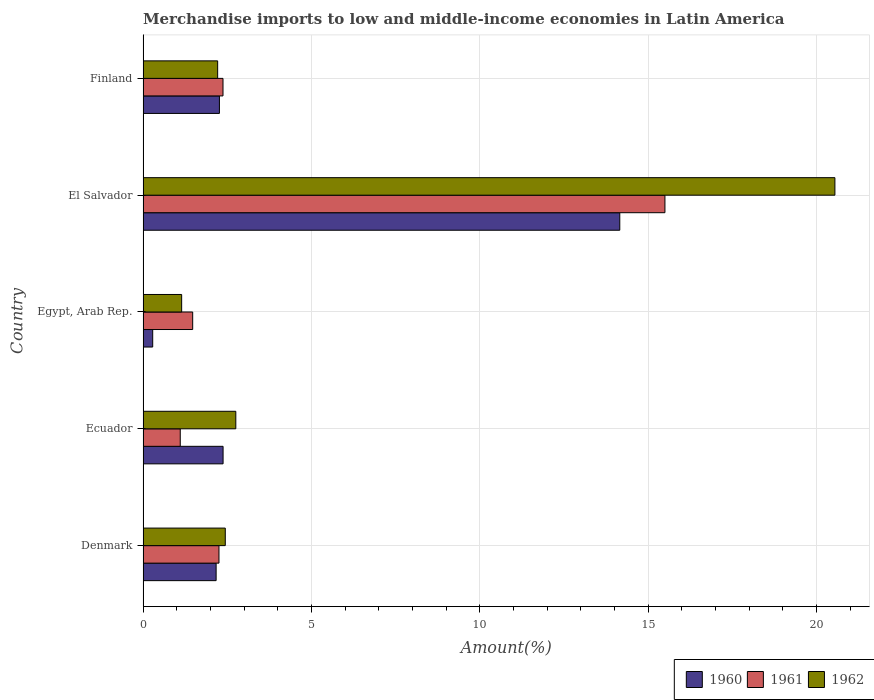How many groups of bars are there?
Make the answer very short. 5. Are the number of bars on each tick of the Y-axis equal?
Your answer should be compact. Yes. What is the label of the 4th group of bars from the top?
Your answer should be very brief. Ecuador. In how many cases, is the number of bars for a given country not equal to the number of legend labels?
Offer a very short reply. 0. What is the percentage of amount earned from merchandise imports in 1961 in Ecuador?
Offer a very short reply. 1.1. Across all countries, what is the maximum percentage of amount earned from merchandise imports in 1962?
Offer a terse response. 20.55. Across all countries, what is the minimum percentage of amount earned from merchandise imports in 1962?
Ensure brevity in your answer.  1.15. In which country was the percentage of amount earned from merchandise imports in 1961 maximum?
Your answer should be compact. El Salvador. In which country was the percentage of amount earned from merchandise imports in 1961 minimum?
Ensure brevity in your answer.  Ecuador. What is the total percentage of amount earned from merchandise imports in 1961 in the graph?
Give a very brief answer. 22.7. What is the difference between the percentage of amount earned from merchandise imports in 1962 in Ecuador and that in El Salvador?
Make the answer very short. -17.79. What is the difference between the percentage of amount earned from merchandise imports in 1961 in El Salvador and the percentage of amount earned from merchandise imports in 1962 in Ecuador?
Your answer should be very brief. 12.74. What is the average percentage of amount earned from merchandise imports in 1961 per country?
Offer a terse response. 4.54. What is the difference between the percentage of amount earned from merchandise imports in 1960 and percentage of amount earned from merchandise imports in 1962 in Finland?
Your response must be concise. 0.05. What is the ratio of the percentage of amount earned from merchandise imports in 1961 in Egypt, Arab Rep. to that in El Salvador?
Offer a very short reply. 0.1. What is the difference between the highest and the second highest percentage of amount earned from merchandise imports in 1960?
Ensure brevity in your answer.  11.78. What is the difference between the highest and the lowest percentage of amount earned from merchandise imports in 1962?
Ensure brevity in your answer.  19.4. In how many countries, is the percentage of amount earned from merchandise imports in 1962 greater than the average percentage of amount earned from merchandise imports in 1962 taken over all countries?
Ensure brevity in your answer.  1. Is the sum of the percentage of amount earned from merchandise imports in 1962 in Denmark and Ecuador greater than the maximum percentage of amount earned from merchandise imports in 1960 across all countries?
Your answer should be compact. No. What does the 2nd bar from the top in Ecuador represents?
Provide a succinct answer. 1961. What does the 3rd bar from the bottom in Ecuador represents?
Ensure brevity in your answer.  1962. Are all the bars in the graph horizontal?
Offer a terse response. Yes. Does the graph contain any zero values?
Provide a short and direct response. No. How many legend labels are there?
Your response must be concise. 3. What is the title of the graph?
Keep it short and to the point. Merchandise imports to low and middle-income economies in Latin America. What is the label or title of the X-axis?
Offer a terse response. Amount(%). What is the Amount(%) of 1960 in Denmark?
Make the answer very short. 2.17. What is the Amount(%) in 1961 in Denmark?
Ensure brevity in your answer.  2.25. What is the Amount(%) of 1962 in Denmark?
Provide a short and direct response. 2.44. What is the Amount(%) of 1960 in Ecuador?
Give a very brief answer. 2.38. What is the Amount(%) of 1961 in Ecuador?
Offer a terse response. 1.1. What is the Amount(%) of 1962 in Ecuador?
Offer a very short reply. 2.75. What is the Amount(%) of 1960 in Egypt, Arab Rep.?
Your answer should be very brief. 0.29. What is the Amount(%) of 1961 in Egypt, Arab Rep.?
Offer a terse response. 1.47. What is the Amount(%) in 1962 in Egypt, Arab Rep.?
Keep it short and to the point. 1.15. What is the Amount(%) in 1960 in El Salvador?
Keep it short and to the point. 14.16. What is the Amount(%) in 1961 in El Salvador?
Ensure brevity in your answer.  15.5. What is the Amount(%) of 1962 in El Salvador?
Your response must be concise. 20.55. What is the Amount(%) in 1960 in Finland?
Offer a terse response. 2.27. What is the Amount(%) of 1961 in Finland?
Provide a succinct answer. 2.37. What is the Amount(%) in 1962 in Finland?
Keep it short and to the point. 2.22. Across all countries, what is the maximum Amount(%) in 1960?
Your response must be concise. 14.16. Across all countries, what is the maximum Amount(%) in 1961?
Offer a terse response. 15.5. Across all countries, what is the maximum Amount(%) in 1962?
Your answer should be very brief. 20.55. Across all countries, what is the minimum Amount(%) in 1960?
Provide a succinct answer. 0.29. Across all countries, what is the minimum Amount(%) of 1961?
Provide a succinct answer. 1.1. Across all countries, what is the minimum Amount(%) in 1962?
Give a very brief answer. 1.15. What is the total Amount(%) of 1960 in the graph?
Keep it short and to the point. 21.26. What is the total Amount(%) in 1961 in the graph?
Keep it short and to the point. 22.7. What is the total Amount(%) of 1962 in the graph?
Your answer should be very brief. 29.1. What is the difference between the Amount(%) in 1960 in Denmark and that in Ecuador?
Ensure brevity in your answer.  -0.21. What is the difference between the Amount(%) in 1961 in Denmark and that in Ecuador?
Keep it short and to the point. 1.15. What is the difference between the Amount(%) in 1962 in Denmark and that in Ecuador?
Ensure brevity in your answer.  -0.31. What is the difference between the Amount(%) in 1960 in Denmark and that in Egypt, Arab Rep.?
Give a very brief answer. 1.88. What is the difference between the Amount(%) in 1961 in Denmark and that in Egypt, Arab Rep.?
Give a very brief answer. 0.78. What is the difference between the Amount(%) in 1962 in Denmark and that in Egypt, Arab Rep.?
Provide a short and direct response. 1.3. What is the difference between the Amount(%) of 1960 in Denmark and that in El Salvador?
Offer a very short reply. -11.99. What is the difference between the Amount(%) of 1961 in Denmark and that in El Salvador?
Keep it short and to the point. -13.24. What is the difference between the Amount(%) of 1962 in Denmark and that in El Salvador?
Give a very brief answer. -18.1. What is the difference between the Amount(%) of 1960 in Denmark and that in Finland?
Make the answer very short. -0.1. What is the difference between the Amount(%) of 1961 in Denmark and that in Finland?
Offer a very short reply. -0.12. What is the difference between the Amount(%) of 1962 in Denmark and that in Finland?
Give a very brief answer. 0.23. What is the difference between the Amount(%) in 1960 in Ecuador and that in Egypt, Arab Rep.?
Your answer should be very brief. 2.09. What is the difference between the Amount(%) of 1961 in Ecuador and that in Egypt, Arab Rep.?
Your answer should be very brief. -0.37. What is the difference between the Amount(%) in 1962 in Ecuador and that in Egypt, Arab Rep.?
Provide a succinct answer. 1.61. What is the difference between the Amount(%) in 1960 in Ecuador and that in El Salvador?
Keep it short and to the point. -11.78. What is the difference between the Amount(%) in 1961 in Ecuador and that in El Salvador?
Keep it short and to the point. -14.39. What is the difference between the Amount(%) of 1962 in Ecuador and that in El Salvador?
Provide a short and direct response. -17.79. What is the difference between the Amount(%) in 1960 in Ecuador and that in Finland?
Offer a very short reply. 0.11. What is the difference between the Amount(%) in 1961 in Ecuador and that in Finland?
Keep it short and to the point. -1.27. What is the difference between the Amount(%) in 1962 in Ecuador and that in Finland?
Your answer should be compact. 0.54. What is the difference between the Amount(%) in 1960 in Egypt, Arab Rep. and that in El Salvador?
Offer a terse response. -13.87. What is the difference between the Amount(%) in 1961 in Egypt, Arab Rep. and that in El Salvador?
Your answer should be very brief. -14.02. What is the difference between the Amount(%) in 1962 in Egypt, Arab Rep. and that in El Salvador?
Offer a terse response. -19.4. What is the difference between the Amount(%) in 1960 in Egypt, Arab Rep. and that in Finland?
Offer a terse response. -1.98. What is the difference between the Amount(%) of 1961 in Egypt, Arab Rep. and that in Finland?
Ensure brevity in your answer.  -0.9. What is the difference between the Amount(%) in 1962 in Egypt, Arab Rep. and that in Finland?
Your response must be concise. -1.07. What is the difference between the Amount(%) in 1960 in El Salvador and that in Finland?
Provide a short and direct response. 11.89. What is the difference between the Amount(%) of 1961 in El Salvador and that in Finland?
Offer a very short reply. 13.12. What is the difference between the Amount(%) of 1962 in El Salvador and that in Finland?
Provide a short and direct response. 18.33. What is the difference between the Amount(%) in 1960 in Denmark and the Amount(%) in 1961 in Ecuador?
Make the answer very short. 1.07. What is the difference between the Amount(%) in 1960 in Denmark and the Amount(%) in 1962 in Ecuador?
Provide a succinct answer. -0.58. What is the difference between the Amount(%) of 1961 in Denmark and the Amount(%) of 1962 in Ecuador?
Make the answer very short. -0.5. What is the difference between the Amount(%) in 1960 in Denmark and the Amount(%) in 1961 in Egypt, Arab Rep.?
Your answer should be very brief. 0.7. What is the difference between the Amount(%) in 1960 in Denmark and the Amount(%) in 1962 in Egypt, Arab Rep.?
Offer a very short reply. 1.02. What is the difference between the Amount(%) in 1961 in Denmark and the Amount(%) in 1962 in Egypt, Arab Rep.?
Provide a succinct answer. 1.11. What is the difference between the Amount(%) in 1960 in Denmark and the Amount(%) in 1961 in El Salvador?
Give a very brief answer. -13.33. What is the difference between the Amount(%) in 1960 in Denmark and the Amount(%) in 1962 in El Salvador?
Offer a very short reply. -18.38. What is the difference between the Amount(%) of 1961 in Denmark and the Amount(%) of 1962 in El Salvador?
Make the answer very short. -18.29. What is the difference between the Amount(%) of 1960 in Denmark and the Amount(%) of 1961 in Finland?
Offer a terse response. -0.2. What is the difference between the Amount(%) in 1960 in Denmark and the Amount(%) in 1962 in Finland?
Ensure brevity in your answer.  -0.05. What is the difference between the Amount(%) of 1961 in Denmark and the Amount(%) of 1962 in Finland?
Provide a succinct answer. 0.04. What is the difference between the Amount(%) in 1960 in Ecuador and the Amount(%) in 1961 in Egypt, Arab Rep.?
Your response must be concise. 0.9. What is the difference between the Amount(%) of 1960 in Ecuador and the Amount(%) of 1962 in Egypt, Arab Rep.?
Offer a very short reply. 1.23. What is the difference between the Amount(%) in 1961 in Ecuador and the Amount(%) in 1962 in Egypt, Arab Rep.?
Provide a short and direct response. -0.04. What is the difference between the Amount(%) of 1960 in Ecuador and the Amount(%) of 1961 in El Salvador?
Offer a very short reply. -13.12. What is the difference between the Amount(%) of 1960 in Ecuador and the Amount(%) of 1962 in El Salvador?
Give a very brief answer. -18.17. What is the difference between the Amount(%) of 1961 in Ecuador and the Amount(%) of 1962 in El Salvador?
Offer a very short reply. -19.44. What is the difference between the Amount(%) of 1960 in Ecuador and the Amount(%) of 1961 in Finland?
Offer a terse response. 0. What is the difference between the Amount(%) of 1960 in Ecuador and the Amount(%) of 1962 in Finland?
Your answer should be very brief. 0.16. What is the difference between the Amount(%) in 1961 in Ecuador and the Amount(%) in 1962 in Finland?
Keep it short and to the point. -1.11. What is the difference between the Amount(%) in 1960 in Egypt, Arab Rep. and the Amount(%) in 1961 in El Salvador?
Your answer should be very brief. -15.21. What is the difference between the Amount(%) in 1960 in Egypt, Arab Rep. and the Amount(%) in 1962 in El Salvador?
Keep it short and to the point. -20.26. What is the difference between the Amount(%) in 1961 in Egypt, Arab Rep. and the Amount(%) in 1962 in El Salvador?
Provide a succinct answer. -19.07. What is the difference between the Amount(%) of 1960 in Egypt, Arab Rep. and the Amount(%) of 1961 in Finland?
Ensure brevity in your answer.  -2.09. What is the difference between the Amount(%) in 1960 in Egypt, Arab Rep. and the Amount(%) in 1962 in Finland?
Provide a succinct answer. -1.93. What is the difference between the Amount(%) of 1961 in Egypt, Arab Rep. and the Amount(%) of 1962 in Finland?
Ensure brevity in your answer.  -0.74. What is the difference between the Amount(%) in 1960 in El Salvador and the Amount(%) in 1961 in Finland?
Your answer should be compact. 11.78. What is the difference between the Amount(%) of 1960 in El Salvador and the Amount(%) of 1962 in Finland?
Offer a very short reply. 11.94. What is the difference between the Amount(%) of 1961 in El Salvador and the Amount(%) of 1962 in Finland?
Your response must be concise. 13.28. What is the average Amount(%) in 1960 per country?
Provide a succinct answer. 4.25. What is the average Amount(%) of 1961 per country?
Your answer should be very brief. 4.54. What is the average Amount(%) in 1962 per country?
Offer a terse response. 5.82. What is the difference between the Amount(%) of 1960 and Amount(%) of 1961 in Denmark?
Make the answer very short. -0.08. What is the difference between the Amount(%) in 1960 and Amount(%) in 1962 in Denmark?
Offer a terse response. -0.27. What is the difference between the Amount(%) in 1961 and Amount(%) in 1962 in Denmark?
Give a very brief answer. -0.19. What is the difference between the Amount(%) of 1960 and Amount(%) of 1961 in Ecuador?
Give a very brief answer. 1.27. What is the difference between the Amount(%) of 1960 and Amount(%) of 1962 in Ecuador?
Offer a terse response. -0.38. What is the difference between the Amount(%) in 1961 and Amount(%) in 1962 in Ecuador?
Your response must be concise. -1.65. What is the difference between the Amount(%) in 1960 and Amount(%) in 1961 in Egypt, Arab Rep.?
Make the answer very short. -1.19. What is the difference between the Amount(%) of 1960 and Amount(%) of 1962 in Egypt, Arab Rep.?
Ensure brevity in your answer.  -0.86. What is the difference between the Amount(%) of 1961 and Amount(%) of 1962 in Egypt, Arab Rep.?
Offer a very short reply. 0.33. What is the difference between the Amount(%) of 1960 and Amount(%) of 1961 in El Salvador?
Your response must be concise. -1.34. What is the difference between the Amount(%) of 1960 and Amount(%) of 1962 in El Salvador?
Provide a short and direct response. -6.39. What is the difference between the Amount(%) of 1961 and Amount(%) of 1962 in El Salvador?
Ensure brevity in your answer.  -5.05. What is the difference between the Amount(%) in 1960 and Amount(%) in 1961 in Finland?
Provide a short and direct response. -0.11. What is the difference between the Amount(%) in 1960 and Amount(%) in 1962 in Finland?
Your answer should be very brief. 0.05. What is the difference between the Amount(%) of 1961 and Amount(%) of 1962 in Finland?
Make the answer very short. 0.16. What is the ratio of the Amount(%) in 1960 in Denmark to that in Ecuador?
Your response must be concise. 0.91. What is the ratio of the Amount(%) of 1961 in Denmark to that in Ecuador?
Make the answer very short. 2.04. What is the ratio of the Amount(%) of 1962 in Denmark to that in Ecuador?
Provide a succinct answer. 0.89. What is the ratio of the Amount(%) in 1960 in Denmark to that in Egypt, Arab Rep.?
Give a very brief answer. 7.58. What is the ratio of the Amount(%) of 1961 in Denmark to that in Egypt, Arab Rep.?
Provide a short and direct response. 1.53. What is the ratio of the Amount(%) of 1962 in Denmark to that in Egypt, Arab Rep.?
Provide a succinct answer. 2.13. What is the ratio of the Amount(%) in 1960 in Denmark to that in El Salvador?
Provide a succinct answer. 0.15. What is the ratio of the Amount(%) of 1961 in Denmark to that in El Salvador?
Give a very brief answer. 0.15. What is the ratio of the Amount(%) in 1962 in Denmark to that in El Salvador?
Your answer should be compact. 0.12. What is the ratio of the Amount(%) of 1960 in Denmark to that in Finland?
Ensure brevity in your answer.  0.96. What is the ratio of the Amount(%) of 1961 in Denmark to that in Finland?
Your response must be concise. 0.95. What is the ratio of the Amount(%) in 1962 in Denmark to that in Finland?
Provide a succinct answer. 1.1. What is the ratio of the Amount(%) in 1960 in Ecuador to that in Egypt, Arab Rep.?
Keep it short and to the point. 8.3. What is the ratio of the Amount(%) of 1961 in Ecuador to that in Egypt, Arab Rep.?
Your answer should be very brief. 0.75. What is the ratio of the Amount(%) of 1962 in Ecuador to that in Egypt, Arab Rep.?
Provide a short and direct response. 2.4. What is the ratio of the Amount(%) in 1960 in Ecuador to that in El Salvador?
Make the answer very short. 0.17. What is the ratio of the Amount(%) of 1961 in Ecuador to that in El Salvador?
Offer a very short reply. 0.07. What is the ratio of the Amount(%) in 1962 in Ecuador to that in El Salvador?
Offer a very short reply. 0.13. What is the ratio of the Amount(%) in 1960 in Ecuador to that in Finland?
Offer a very short reply. 1.05. What is the ratio of the Amount(%) in 1961 in Ecuador to that in Finland?
Provide a succinct answer. 0.47. What is the ratio of the Amount(%) of 1962 in Ecuador to that in Finland?
Provide a succinct answer. 1.24. What is the ratio of the Amount(%) of 1960 in Egypt, Arab Rep. to that in El Salvador?
Your answer should be compact. 0.02. What is the ratio of the Amount(%) of 1961 in Egypt, Arab Rep. to that in El Salvador?
Make the answer very short. 0.1. What is the ratio of the Amount(%) of 1962 in Egypt, Arab Rep. to that in El Salvador?
Offer a terse response. 0.06. What is the ratio of the Amount(%) of 1960 in Egypt, Arab Rep. to that in Finland?
Offer a very short reply. 0.13. What is the ratio of the Amount(%) in 1961 in Egypt, Arab Rep. to that in Finland?
Offer a terse response. 0.62. What is the ratio of the Amount(%) of 1962 in Egypt, Arab Rep. to that in Finland?
Provide a short and direct response. 0.52. What is the ratio of the Amount(%) of 1960 in El Salvador to that in Finland?
Provide a short and direct response. 6.24. What is the ratio of the Amount(%) in 1961 in El Salvador to that in Finland?
Your answer should be compact. 6.53. What is the ratio of the Amount(%) in 1962 in El Salvador to that in Finland?
Your answer should be compact. 9.27. What is the difference between the highest and the second highest Amount(%) of 1960?
Ensure brevity in your answer.  11.78. What is the difference between the highest and the second highest Amount(%) of 1961?
Your answer should be very brief. 13.12. What is the difference between the highest and the second highest Amount(%) of 1962?
Give a very brief answer. 17.79. What is the difference between the highest and the lowest Amount(%) in 1960?
Your response must be concise. 13.87. What is the difference between the highest and the lowest Amount(%) in 1961?
Make the answer very short. 14.39. What is the difference between the highest and the lowest Amount(%) in 1962?
Your answer should be compact. 19.4. 